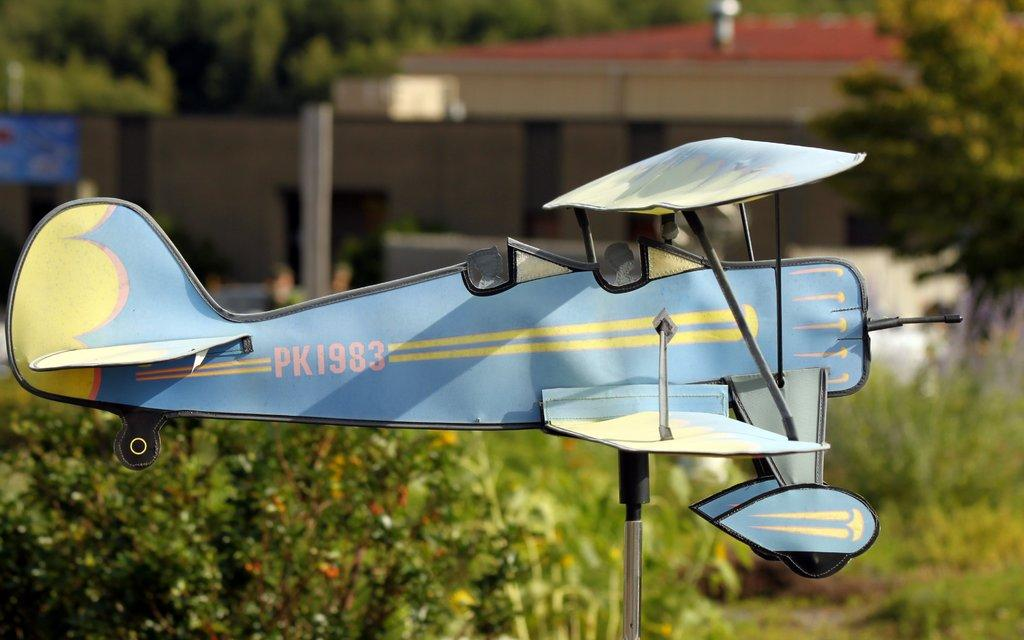<image>
Give a short and clear explanation of the subsequent image. A model plane with PK 1983 painted on the side is held up by a metal rod in a garden. 